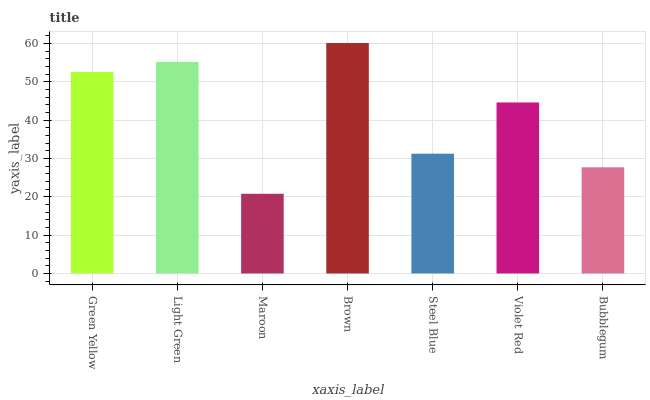Is Maroon the minimum?
Answer yes or no. Yes. Is Brown the maximum?
Answer yes or no. Yes. Is Light Green the minimum?
Answer yes or no. No. Is Light Green the maximum?
Answer yes or no. No. Is Light Green greater than Green Yellow?
Answer yes or no. Yes. Is Green Yellow less than Light Green?
Answer yes or no. Yes. Is Green Yellow greater than Light Green?
Answer yes or no. No. Is Light Green less than Green Yellow?
Answer yes or no. No. Is Violet Red the high median?
Answer yes or no. Yes. Is Violet Red the low median?
Answer yes or no. Yes. Is Light Green the high median?
Answer yes or no. No. Is Brown the low median?
Answer yes or no. No. 